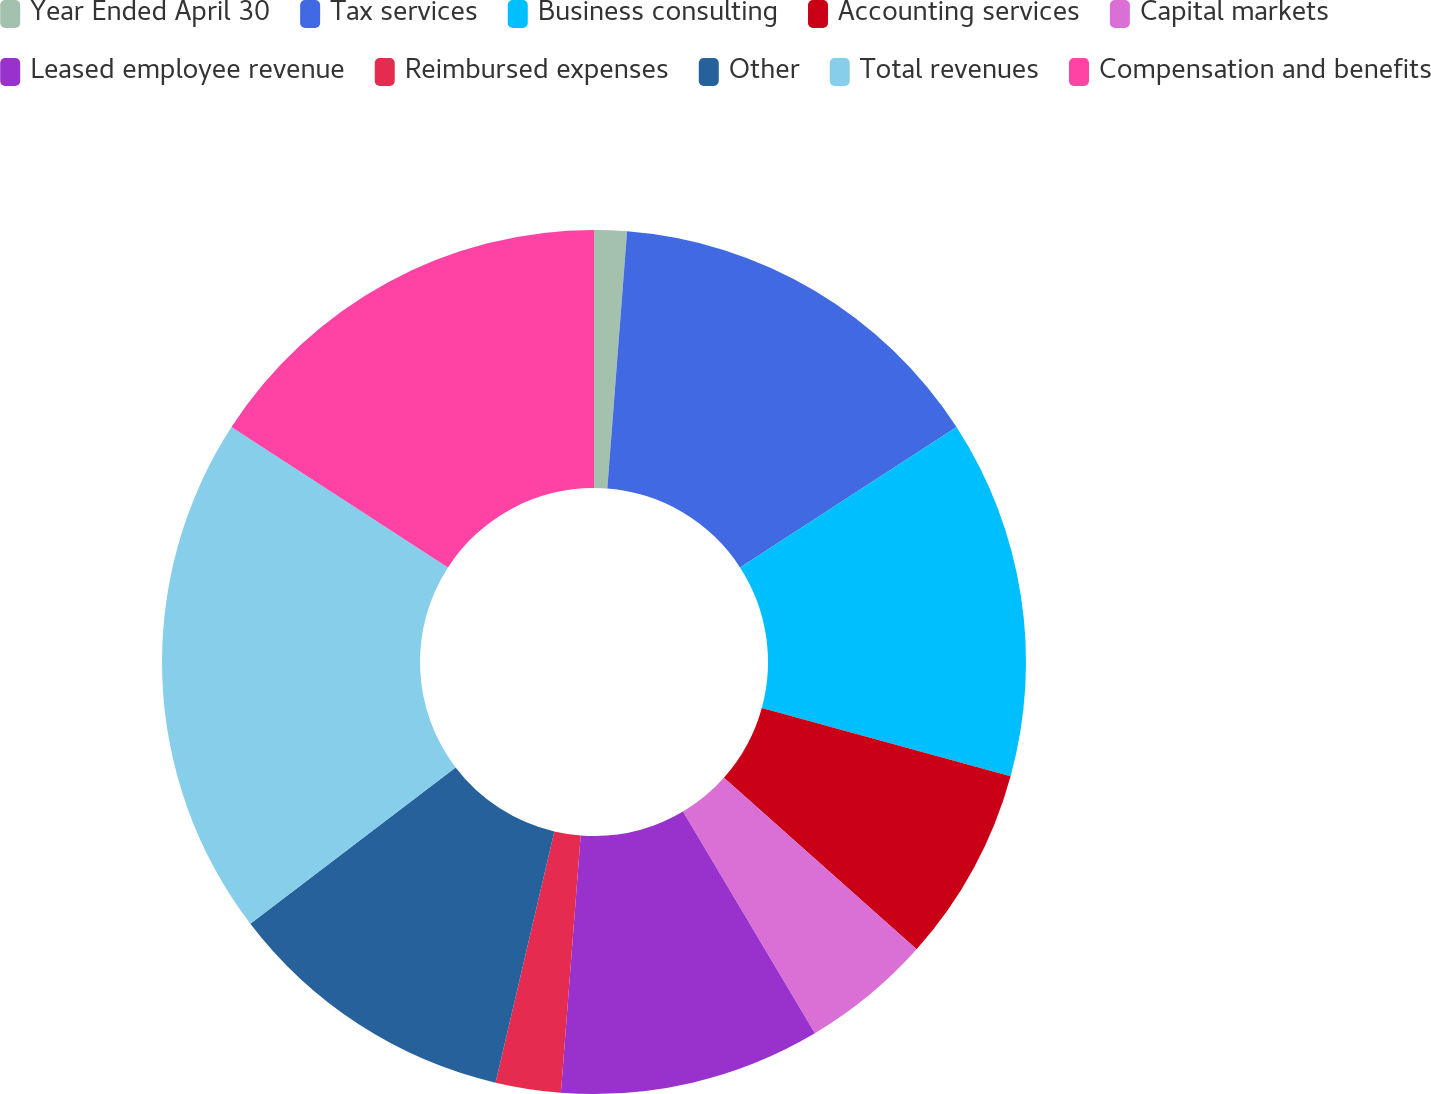Convert chart. <chart><loc_0><loc_0><loc_500><loc_500><pie_chart><fcel>Year Ended April 30<fcel>Tax services<fcel>Business consulting<fcel>Accounting services<fcel>Capital markets<fcel>Leased employee revenue<fcel>Reimbursed expenses<fcel>Other<fcel>Total revenues<fcel>Compensation and benefits<nl><fcel>1.22%<fcel>14.63%<fcel>13.41%<fcel>7.32%<fcel>4.88%<fcel>9.76%<fcel>2.44%<fcel>10.98%<fcel>19.51%<fcel>15.85%<nl></chart> 